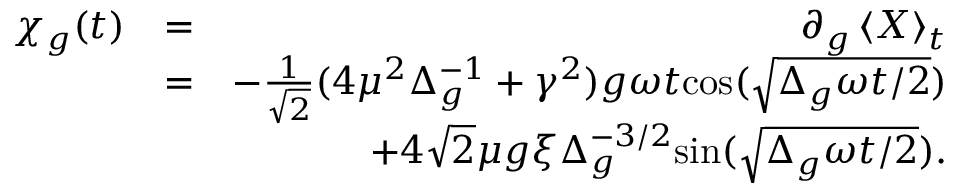Convert formula to latex. <formula><loc_0><loc_0><loc_500><loc_500>\begin{array} { r l r } { \chi _ { g } ( t ) } & { = } & { \partial _ { g } \left \langle { X } \right \rangle _ { t } } \\ & { = } & { - \frac { 1 } { \sqrt { 2 } } ( 4 \mu ^ { 2 } \Delta _ { g } ^ { - 1 } + \gamma ^ { 2 } ) g \omega t { \cos } ( \sqrt { \Delta _ { g } \omega t / 2 } ) } \\ & { + 4 \sqrt { 2 } \mu g \xi \Delta _ { g } ^ { - 3 / 2 } { \sin } ( \sqrt { \Delta _ { g } \omega t / 2 } ) . } \end{array}</formula> 